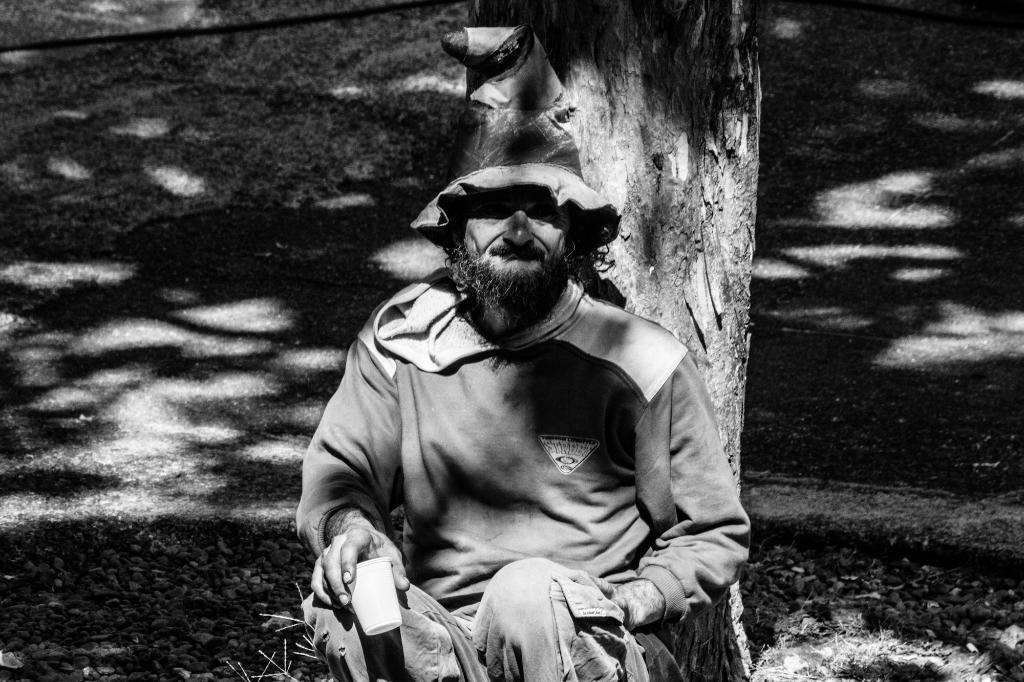Could you give a brief overview of what you see in this image? This is a black and white image. In this image we can see a man wearing hat and holding a cup. In the back we can see a tree trunk. 